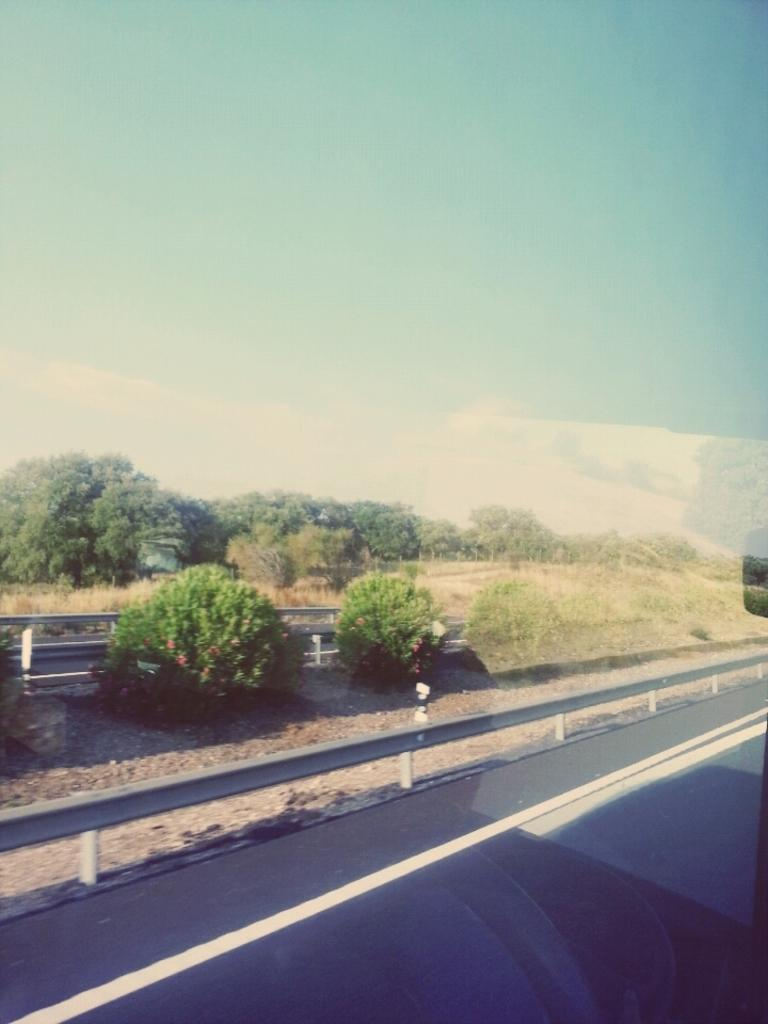What type of vegetation can be seen in the image? There are trees in the image. What else can be seen on the ground in the image? There is grass in the image. What is the purpose of the structure visible in the image? The fence in the image serves as a barrier or boundary. What is visible at the top of the image? The sky is visible at the top of the image. Can you hear the thunder in the image? There is no sound present in the image, so it is not possible to hear thunder. How does the fly navigate through the image? There are no flies present in the image, so it is not possible to describe their navigation. 